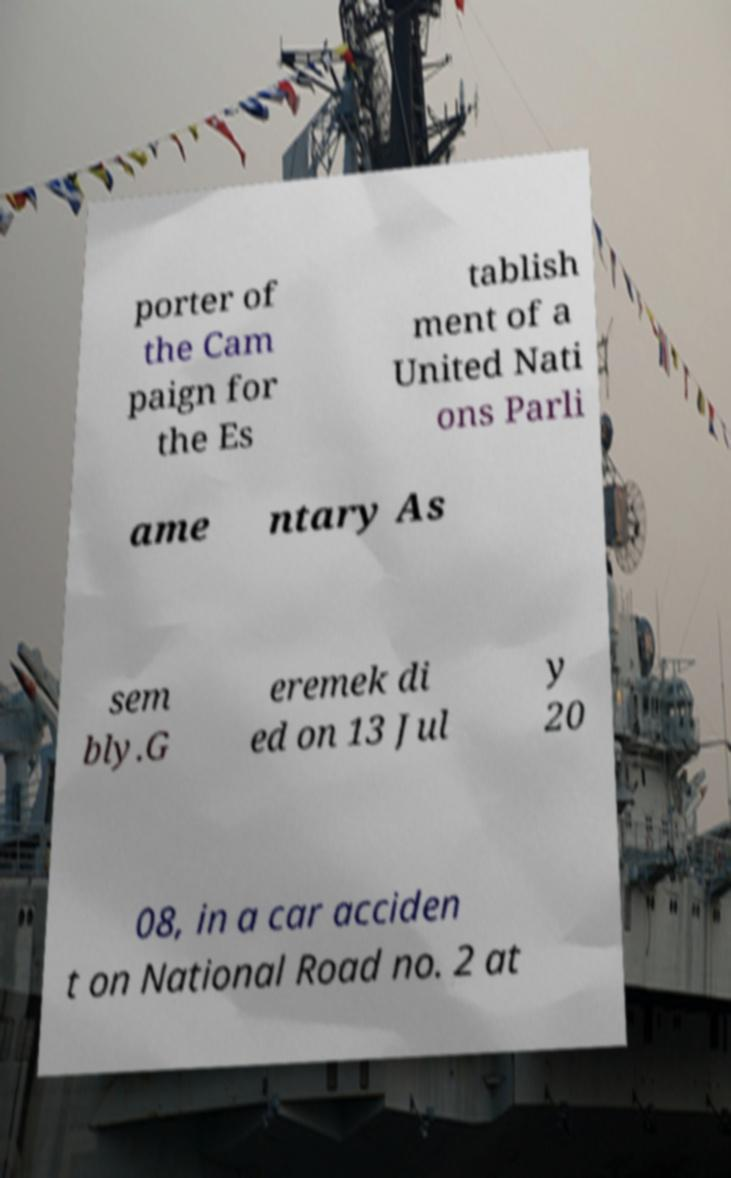Please identify and transcribe the text found in this image. porter of the Cam paign for the Es tablish ment of a United Nati ons Parli ame ntary As sem bly.G eremek di ed on 13 Jul y 20 08, in a car acciden t on National Road no. 2 at 